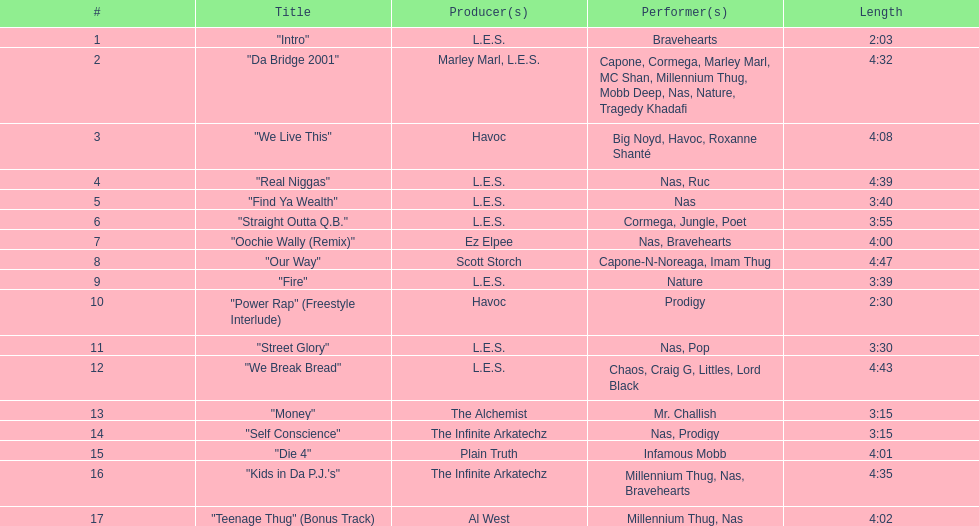Who were the performers in the concluding track? Millennium Thug, Nas. 